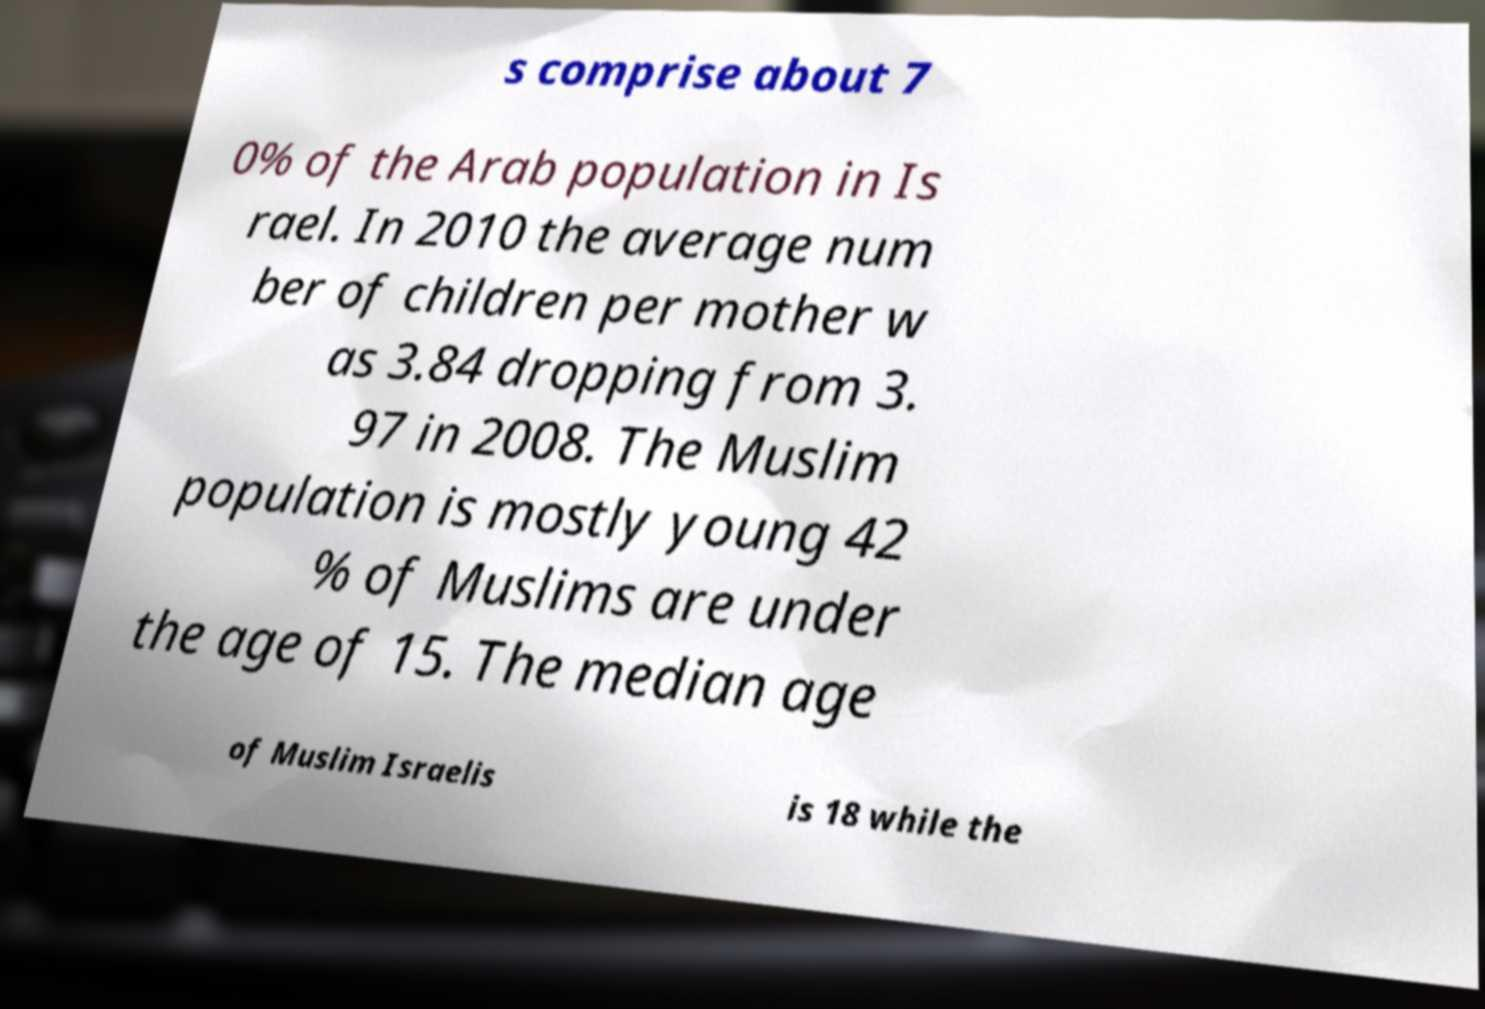Can you accurately transcribe the text from the provided image for me? s comprise about 7 0% of the Arab population in Is rael. In 2010 the average num ber of children per mother w as 3.84 dropping from 3. 97 in 2008. The Muslim population is mostly young 42 % of Muslims are under the age of 15. The median age of Muslim Israelis is 18 while the 